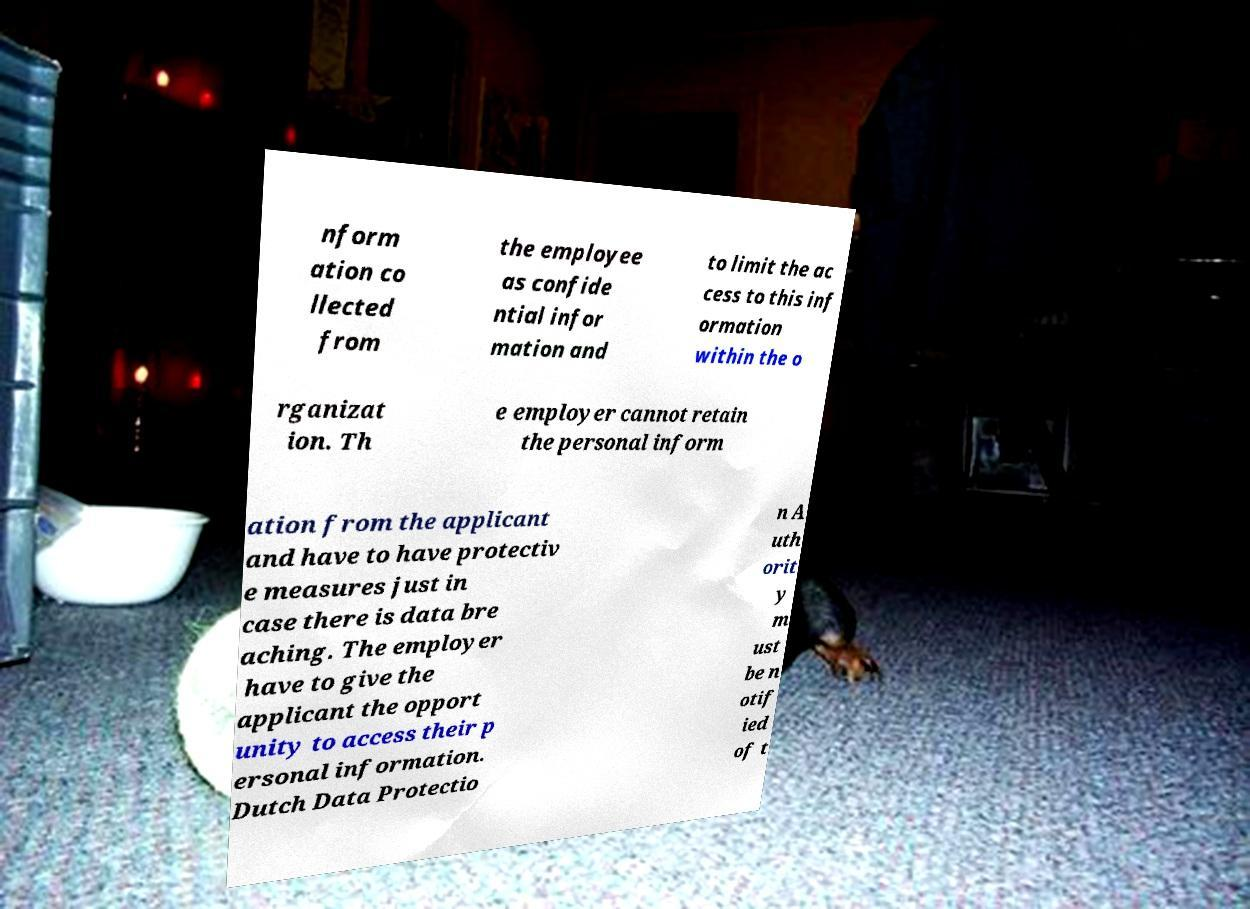Could you assist in decoding the text presented in this image and type it out clearly? nform ation co llected from the employee as confide ntial infor mation and to limit the ac cess to this inf ormation within the o rganizat ion. Th e employer cannot retain the personal inform ation from the applicant and have to have protectiv e measures just in case there is data bre aching. The employer have to give the applicant the opport unity to access their p ersonal information. Dutch Data Protectio n A uth orit y m ust be n otif ied of t 